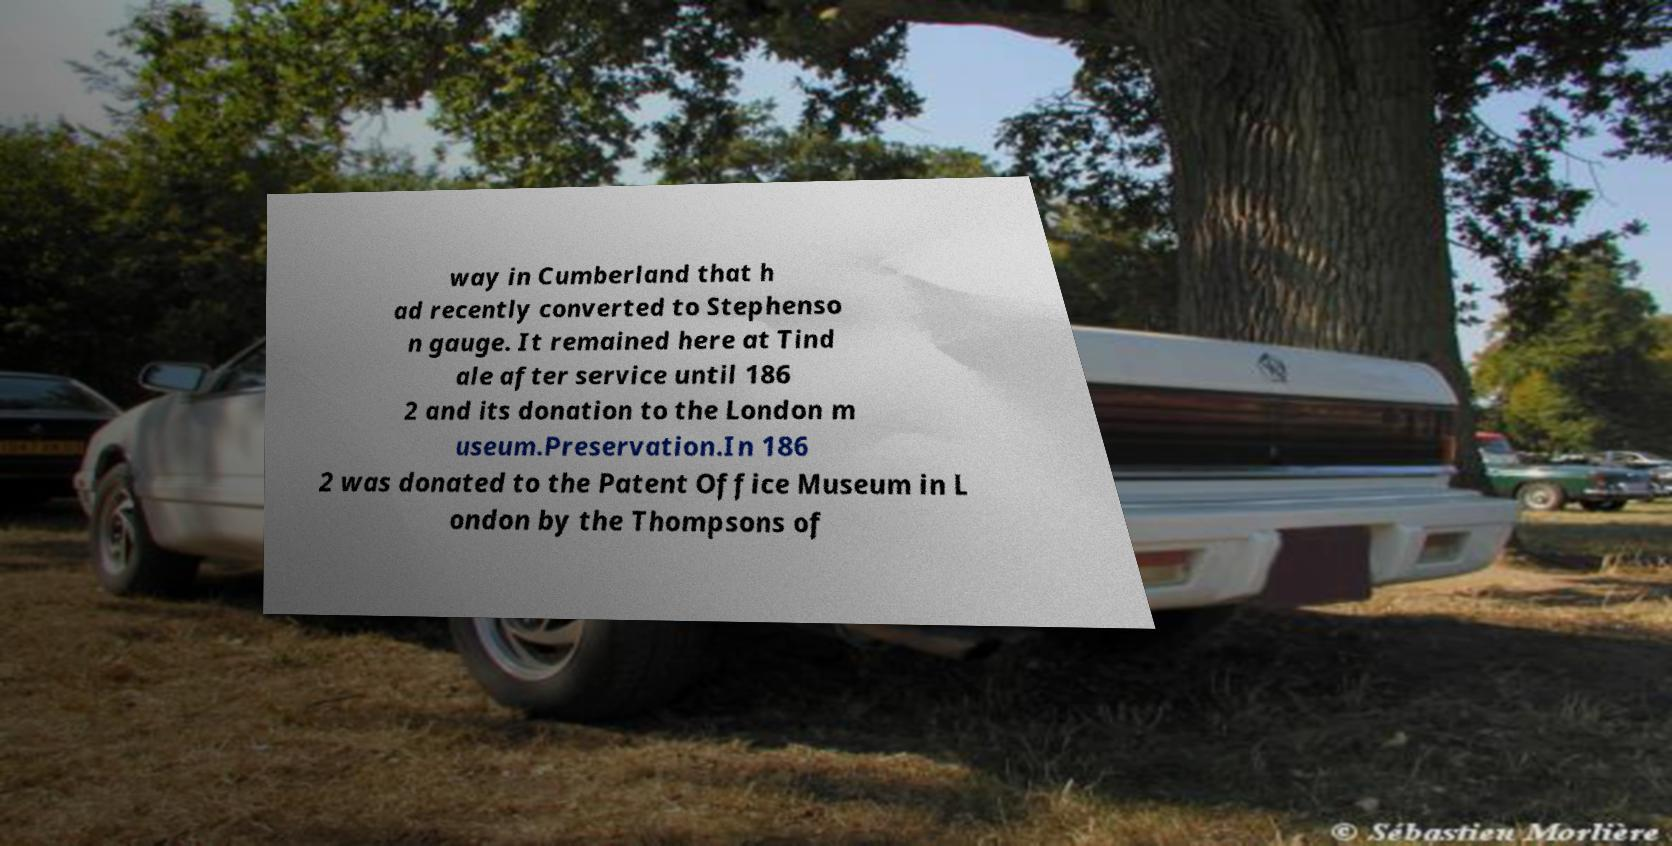For documentation purposes, I need the text within this image transcribed. Could you provide that? way in Cumberland that h ad recently converted to Stephenso n gauge. It remained here at Tind ale after service until 186 2 and its donation to the London m useum.Preservation.In 186 2 was donated to the Patent Office Museum in L ondon by the Thompsons of 